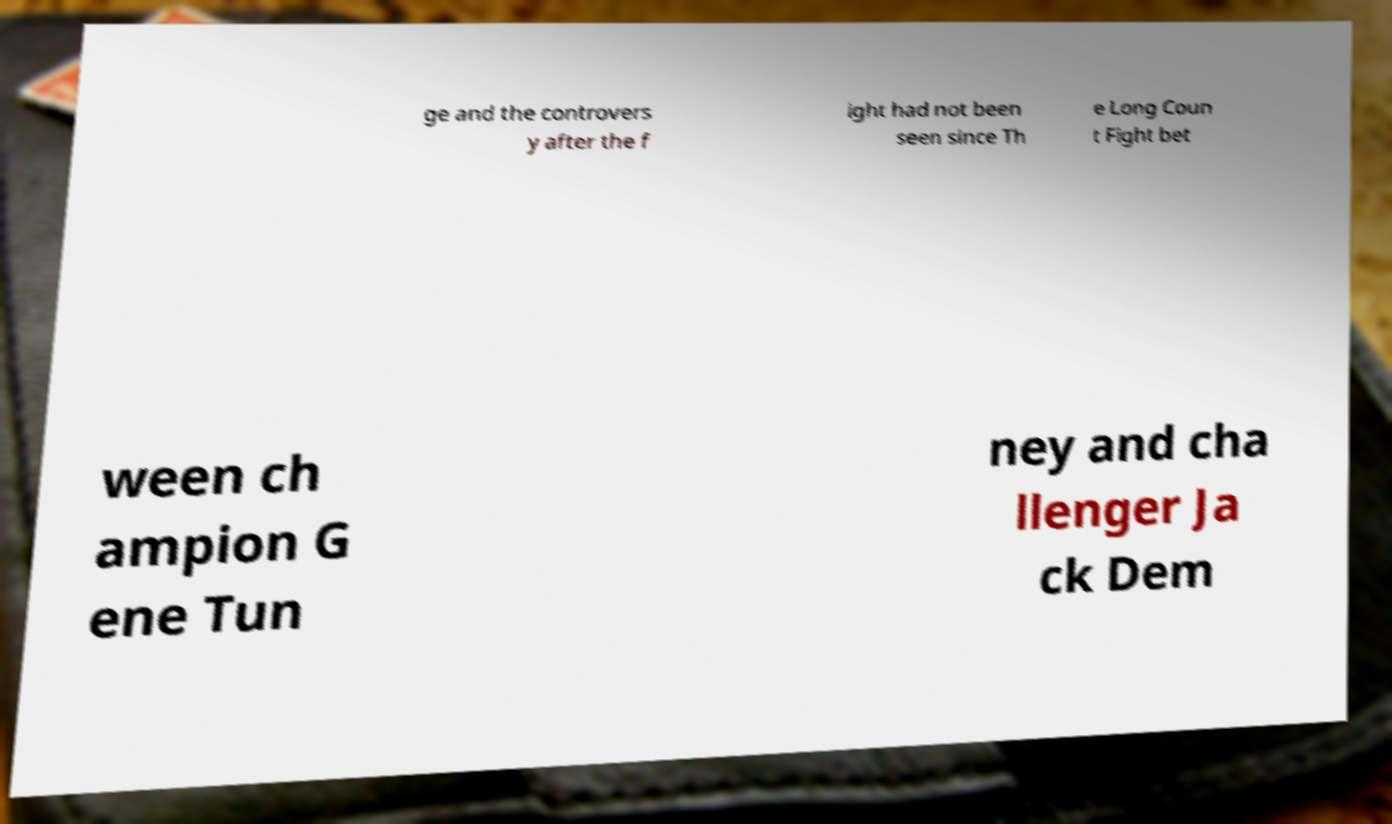Can you read and provide the text displayed in the image?This photo seems to have some interesting text. Can you extract and type it out for me? ge and the controvers y after the f ight had not been seen since Th e Long Coun t Fight bet ween ch ampion G ene Tun ney and cha llenger Ja ck Dem 